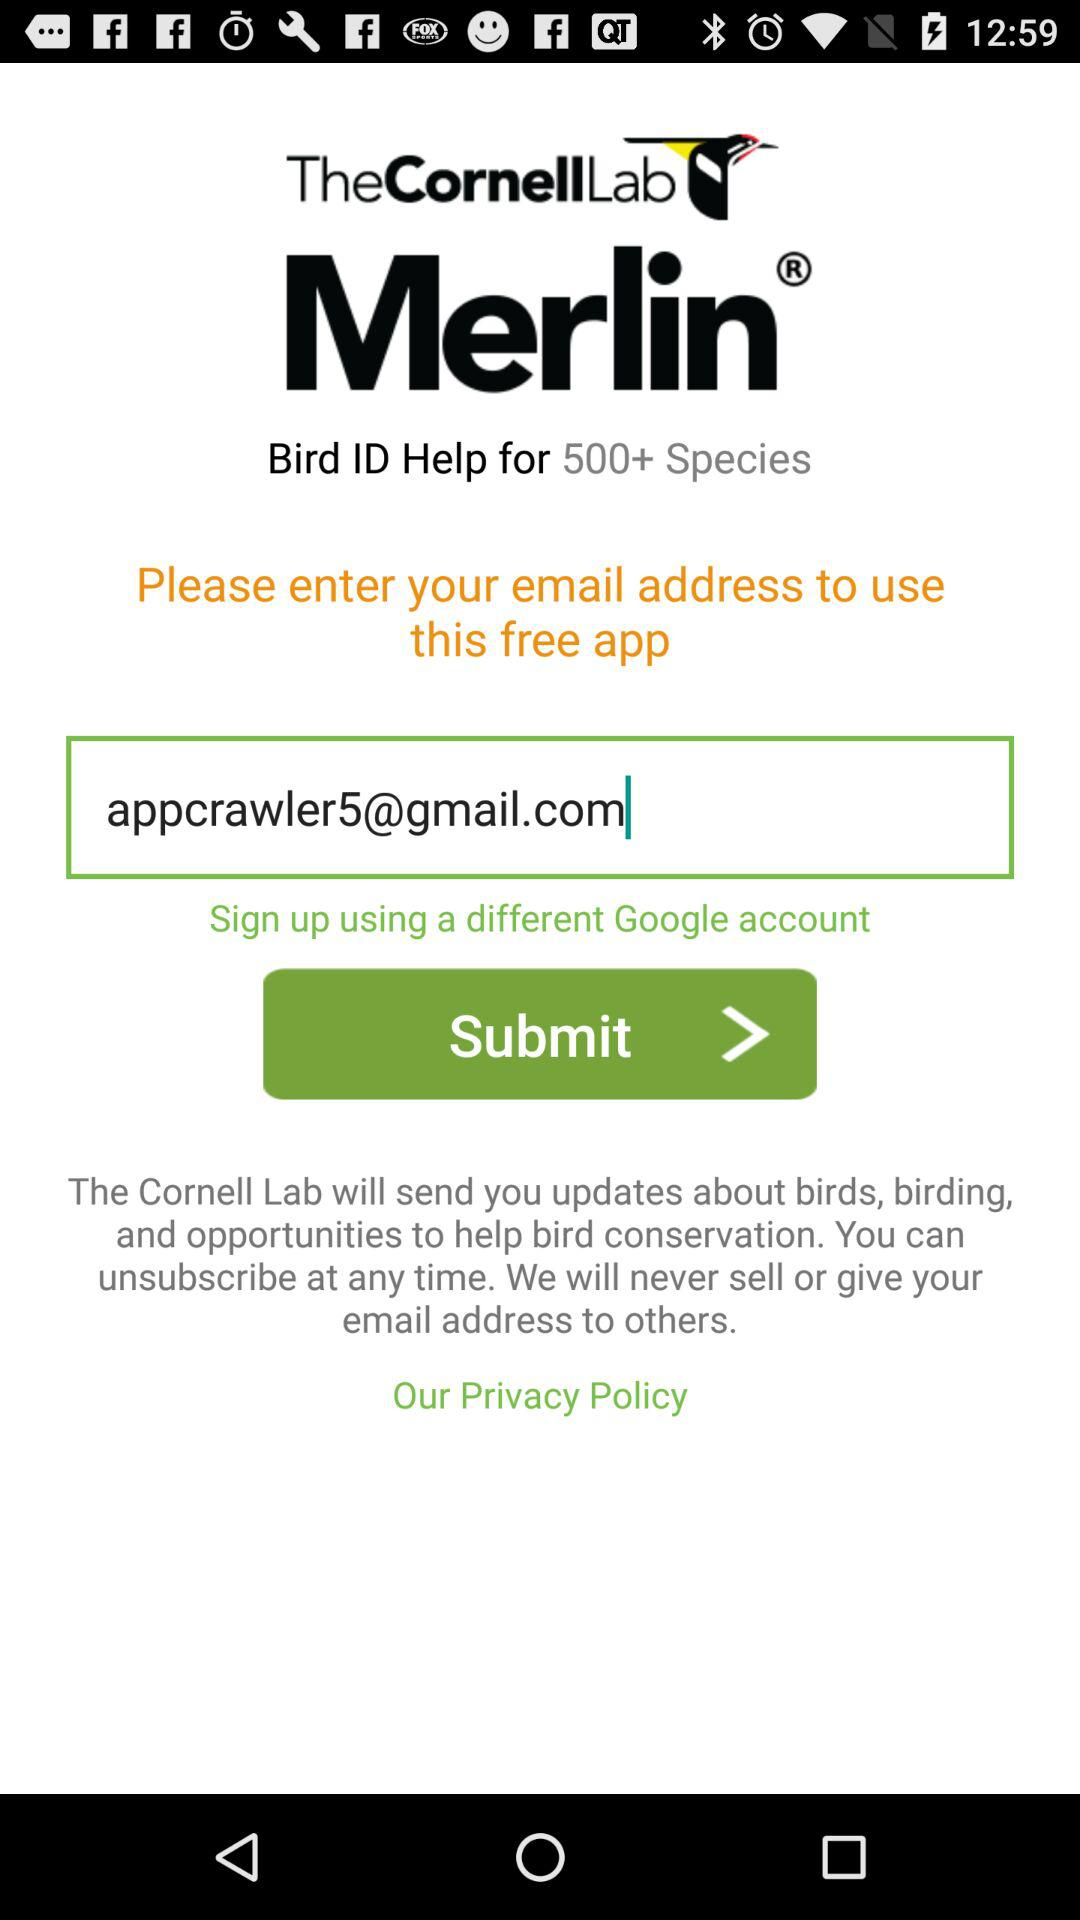What is the name of the application? The name of the application is "Merlin". 